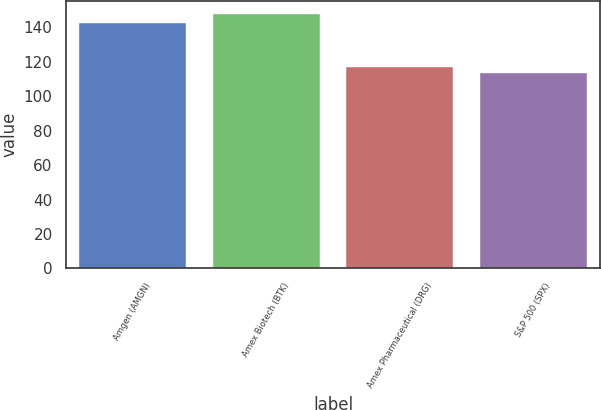Convert chart. <chart><loc_0><loc_0><loc_500><loc_500><bar_chart><fcel>Amgen (AMGN)<fcel>Amex Biotech (BTK)<fcel>Amex Pharmaceutical (DRG)<fcel>S&P 500 (SPX)<nl><fcel>142.32<fcel>147.91<fcel>117.1<fcel>113.68<nl></chart> 